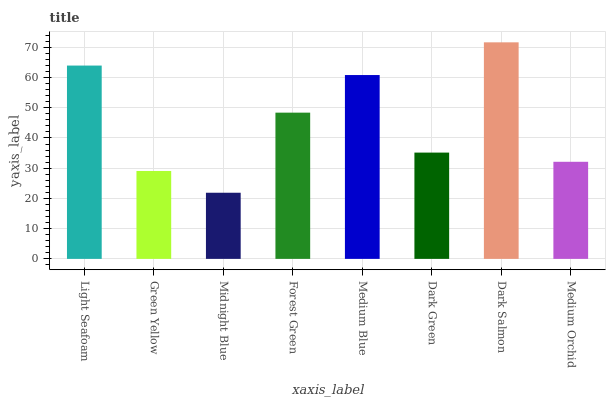Is Midnight Blue the minimum?
Answer yes or no. Yes. Is Dark Salmon the maximum?
Answer yes or no. Yes. Is Green Yellow the minimum?
Answer yes or no. No. Is Green Yellow the maximum?
Answer yes or no. No. Is Light Seafoam greater than Green Yellow?
Answer yes or no. Yes. Is Green Yellow less than Light Seafoam?
Answer yes or no. Yes. Is Green Yellow greater than Light Seafoam?
Answer yes or no. No. Is Light Seafoam less than Green Yellow?
Answer yes or no. No. Is Forest Green the high median?
Answer yes or no. Yes. Is Dark Green the low median?
Answer yes or no. Yes. Is Dark Green the high median?
Answer yes or no. No. Is Dark Salmon the low median?
Answer yes or no. No. 